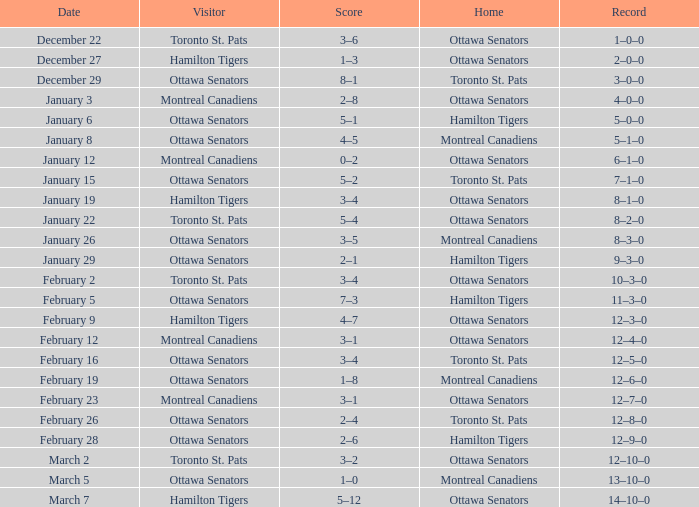Who were the local players when the away team was the montreal canadiens on february 12? Ottawa Senators. 